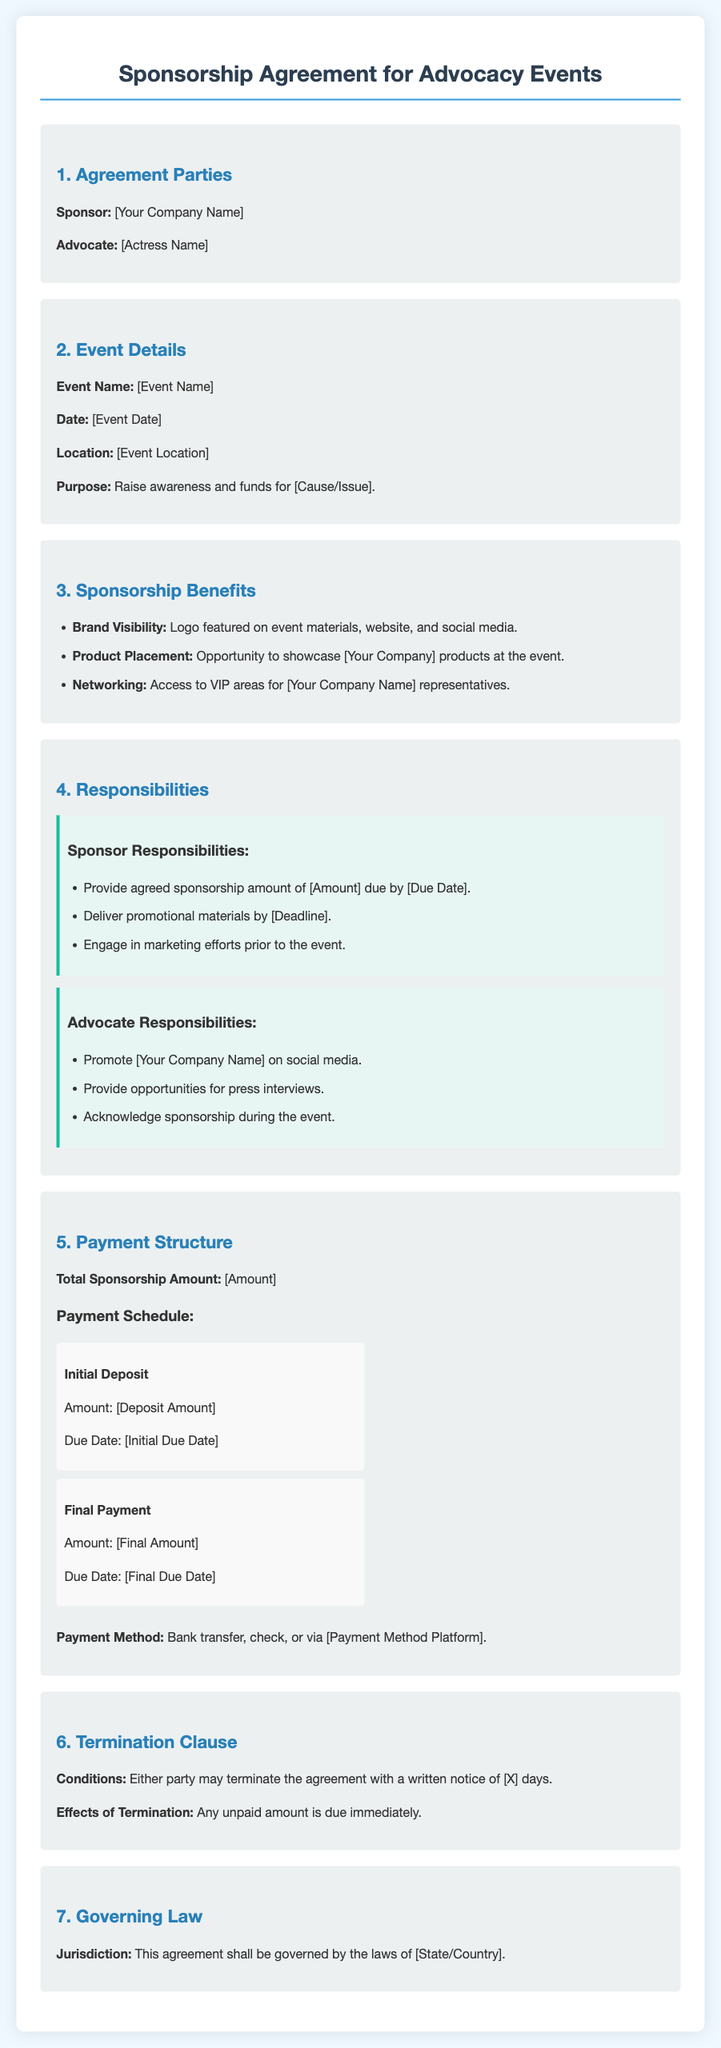What is the sponsor's name? The sponsor's name is the company shown at the beginning of the document under "Sponsor."
Answer: [Your Company Name] What is the total sponsorship amount? The total sponsorship amount is listed in the payment structure section of the document.
Answer: [Amount] What is the event's purpose? The purpose of the event is stated in the event details section.
Answer: Raise awareness and funds for [Cause/Issue] When is the initial deposit due? The due date for the initial deposit is mentioned in the payment schedule section.
Answer: [Initial Due Date] What are the advocate's responsibilities? The advocate's responsibilities are listed separately in the responsibilities section.
Answer: Promote [Your Company Name] on social media; provide opportunities for press interviews; acknowledge sponsorship during the event What type of law governs this agreement? The governing law is specified in the relevant section of the document.
Answer: [State/Country] How many days notice is required for termination? The notice period for termination is indicated in the termination clause section.
Answer: [X] What kind of payment methods are accepted? The accepted payment methods are stated at the end of the payment structure section.
Answer: Bank transfer, check, or via [Payment Method Platform] 